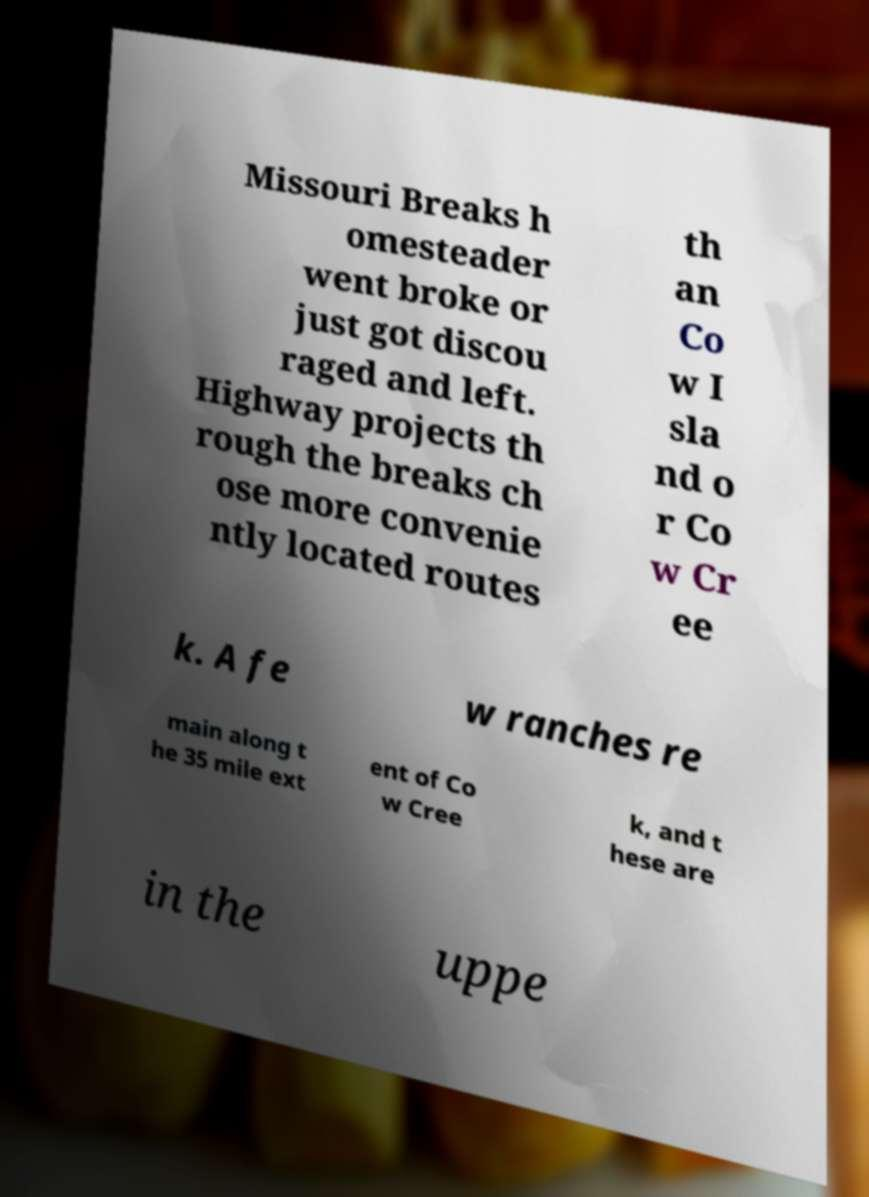Can you read and provide the text displayed in the image?This photo seems to have some interesting text. Can you extract and type it out for me? Missouri Breaks h omesteader went broke or just got discou raged and left. Highway projects th rough the breaks ch ose more convenie ntly located routes th an Co w I sla nd o r Co w Cr ee k. A fe w ranches re main along t he 35 mile ext ent of Co w Cree k, and t hese are in the uppe 